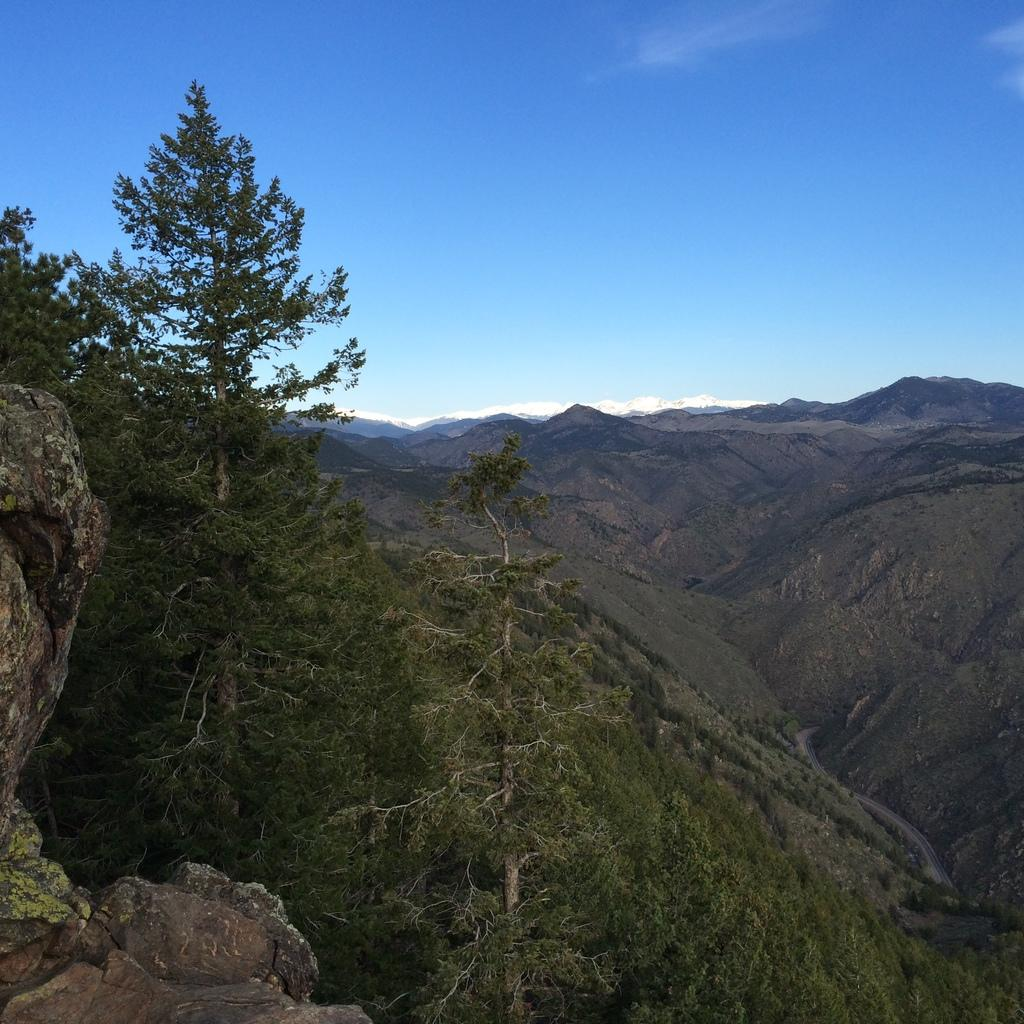What type of vegetation can be seen in the image? There is a group of trees in the image. What can be seen in the distance behind the trees? There are hills visible in the background of the image. What part of the natural environment is visible in the image? The sky is visible in the image. How would you describe the weather based on the appearance of the sky? The sky appears to be cloudy in the image. Can you see any signs of love between the trees in the image? There is no indication of love or any emotional connection between the trees in the image, as trees are inanimate objects. 